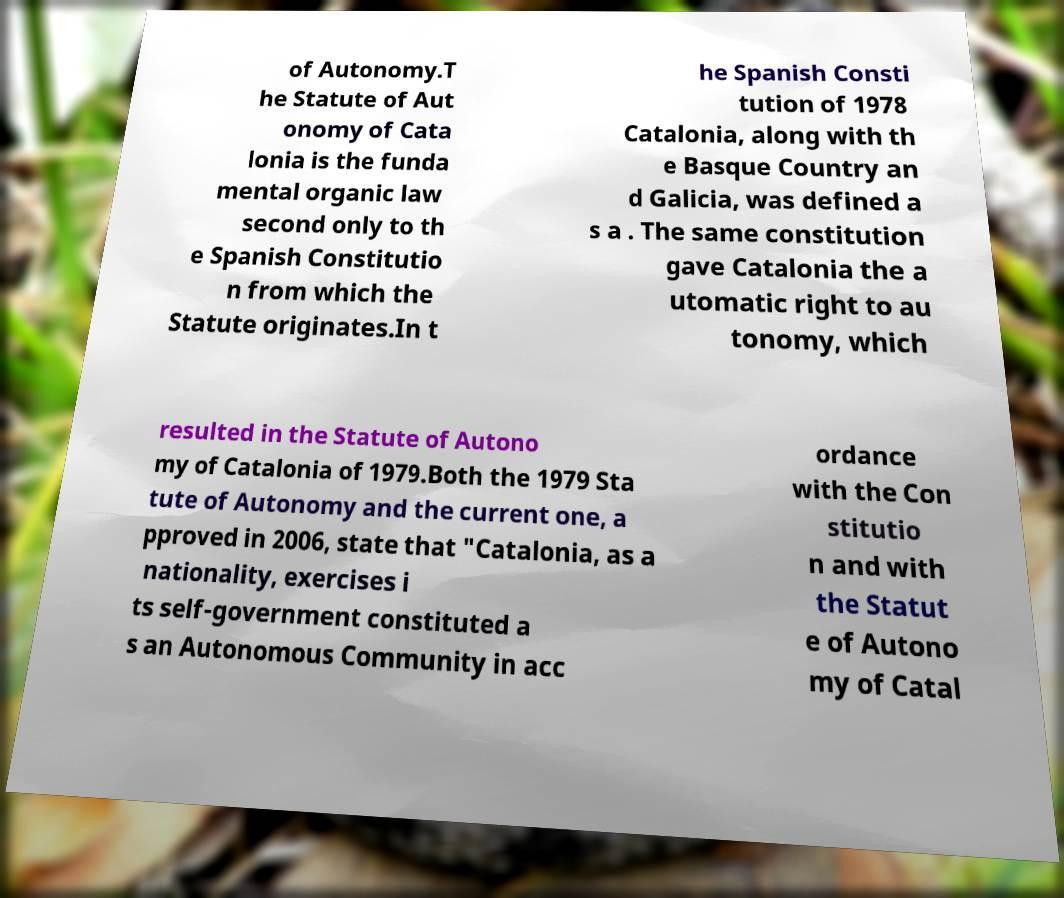For documentation purposes, I need the text within this image transcribed. Could you provide that? of Autonomy.T he Statute of Aut onomy of Cata lonia is the funda mental organic law second only to th e Spanish Constitutio n from which the Statute originates.In t he Spanish Consti tution of 1978 Catalonia, along with th e Basque Country an d Galicia, was defined a s a . The same constitution gave Catalonia the a utomatic right to au tonomy, which resulted in the Statute of Autono my of Catalonia of 1979.Both the 1979 Sta tute of Autonomy and the current one, a pproved in 2006, state that "Catalonia, as a nationality, exercises i ts self-government constituted a s an Autonomous Community in acc ordance with the Con stitutio n and with the Statut e of Autono my of Catal 